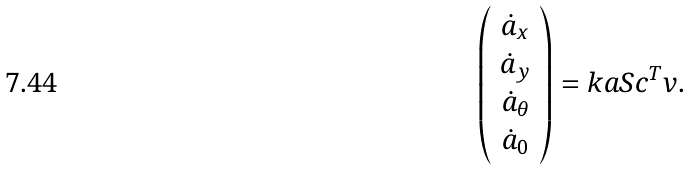<formula> <loc_0><loc_0><loc_500><loc_500>\left ( \begin{array} c \dot { a } _ { x } \\ \dot { a } _ { y } \\ \dot { a } _ { \theta } \\ \dot { a } _ { 0 } \end{array} \right ) = k a S c ^ { T } v .</formula> 